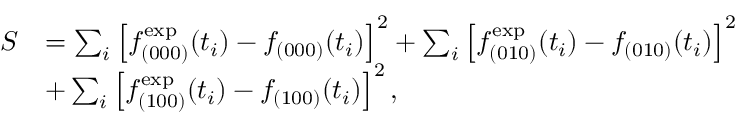<formula> <loc_0><loc_0><loc_500><loc_500>\begin{array} { r l } { S } & { = \sum _ { i } \left [ f _ { ( 0 0 0 ) } ^ { e x p } ( t _ { i } ) - f _ { ( 0 0 0 ) } ( t _ { i } ) \right ] ^ { 2 } + \sum _ { i } \left [ f _ { ( 0 1 0 ) } ^ { e x p } ( t _ { i } ) - f _ { ( 0 1 0 ) } ( t _ { i } ) \right ] ^ { 2 } } \\ & { + \sum _ { i } \left [ f _ { ( 1 0 0 ) } ^ { e x p } ( t _ { i } ) - f _ { ( 1 0 0 ) } ( t _ { i } ) \right ] ^ { 2 } , } \end{array}</formula> 